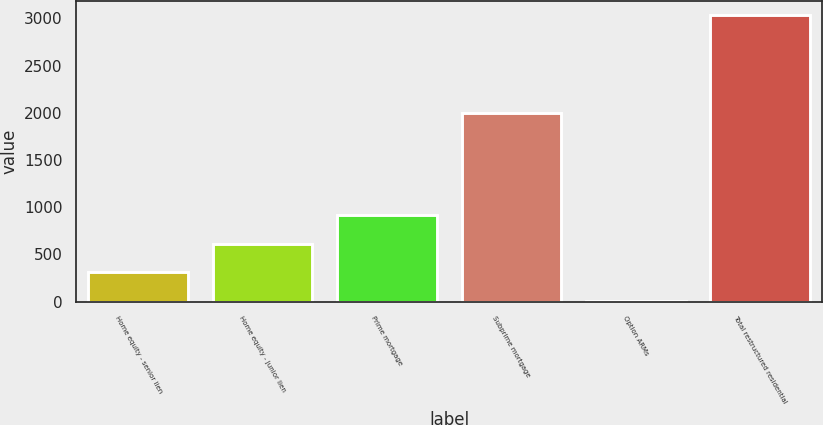Convert chart to OTSL. <chart><loc_0><loc_0><loc_500><loc_500><bar_chart><fcel>Home equity - senior lien<fcel>Home equity - junior lien<fcel>Prime mortgage<fcel>Subprime mortgage<fcel>Option ARMs<fcel>Total restructured residential<nl><fcel>310.2<fcel>612.4<fcel>914.6<fcel>1998<fcel>8<fcel>3030<nl></chart> 